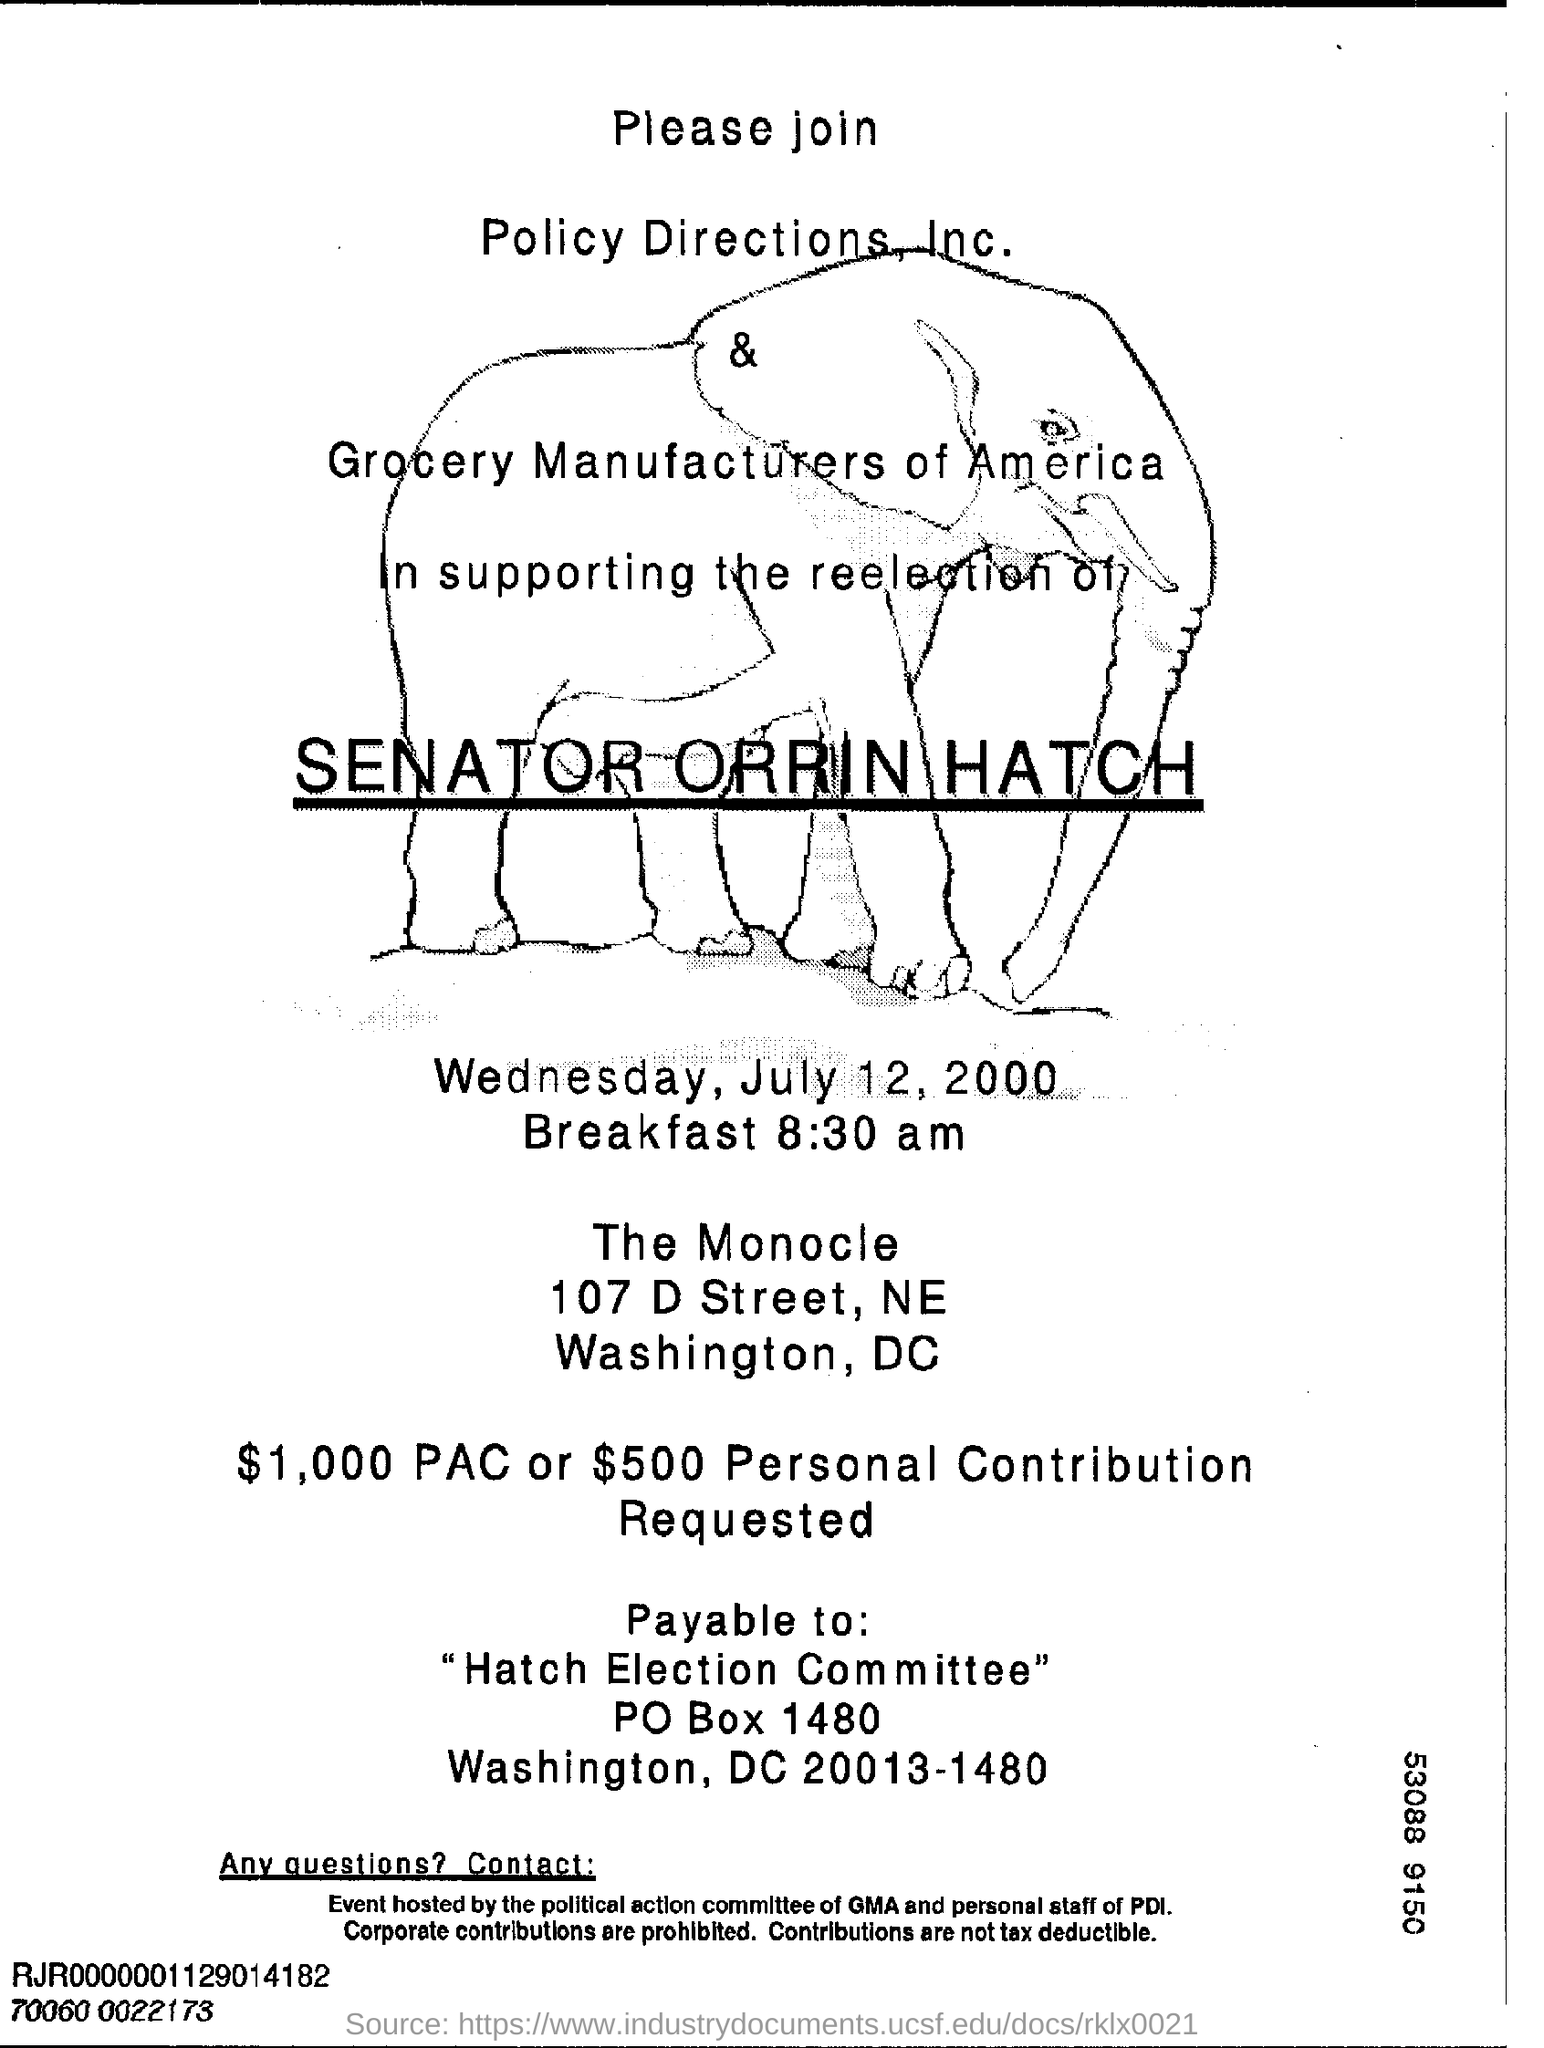How many dollars of personal contribution is requested?
Your response must be concise. $500. What is the P O Box No of Hatch Election Committee?
Make the answer very short. 1480. 